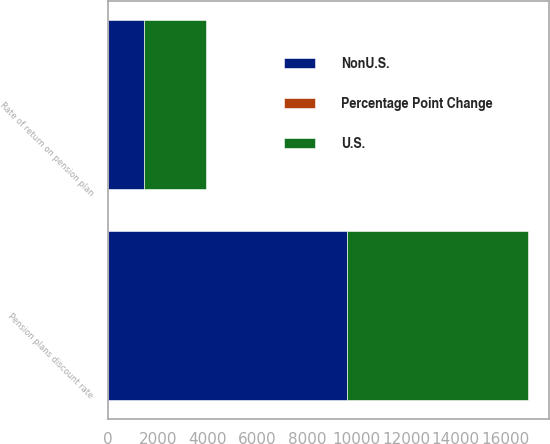<chart> <loc_0><loc_0><loc_500><loc_500><stacked_bar_chart><ecel><fcel>Pension plans discount rate<fcel>Rate of return on pension plan<nl><fcel>Percentage Point Change<fcel>0.25<fcel>1<nl><fcel>NonU.S.<fcel>9606<fcel>1437<nl><fcel>U.S.<fcel>7308<fcel>2498<nl></chart> 